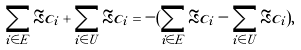<formula> <loc_0><loc_0><loc_500><loc_500>\sum _ { i \in E } \Re c _ { i } + \sum _ { i \in U } \Re c _ { i } = - ( \sum _ { i \in E } \Re c _ { i } - \sum _ { i \in U } \Re c _ { i } ) ,</formula> 